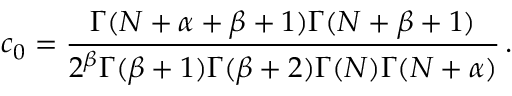Convert formula to latex. <formula><loc_0><loc_0><loc_500><loc_500>c _ { 0 } = { \frac { \Gamma ( N + \alpha + \beta + 1 ) \Gamma ( N + \beta + 1 ) } { 2 ^ { \beta } \Gamma ( \beta + 1 ) \Gamma ( \beta + 2 ) \Gamma ( N ) \Gamma ( N + \alpha ) } } \, .</formula> 